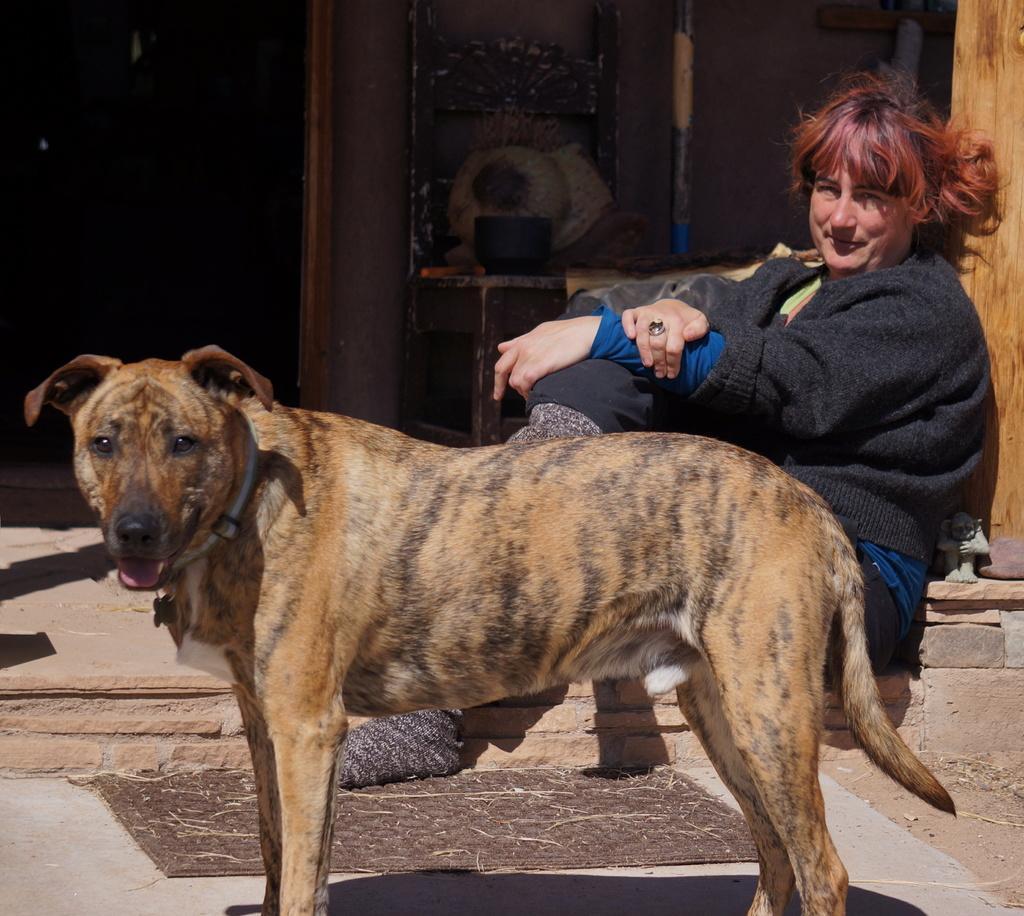Please provide a concise description of this image. In this picture we can see women wore sweater sitting and smiling and beside to her dog standing on floor and in background we can see wall, banner, pole, table, pillar. 